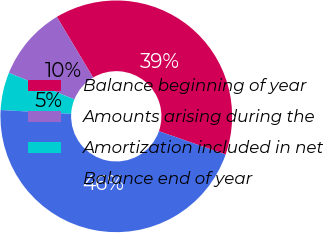<chart> <loc_0><loc_0><loc_500><loc_500><pie_chart><fcel>Balance beginning of year<fcel>Amounts arising during the<fcel>Amortization included in net<fcel>Balance end of year<nl><fcel>38.93%<fcel>10.31%<fcel>5.25%<fcel>45.52%<nl></chart> 